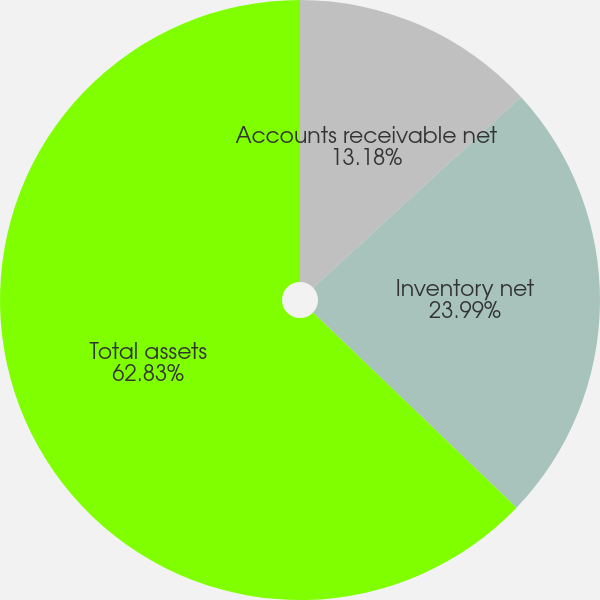<chart> <loc_0><loc_0><loc_500><loc_500><pie_chart><fcel>Accounts receivable net<fcel>Inventory net<fcel>Total assets<nl><fcel>13.18%<fcel>23.99%<fcel>62.83%<nl></chart> 